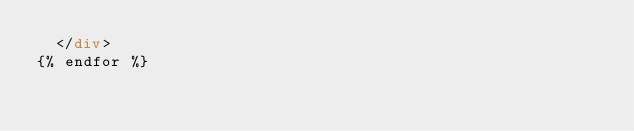<code> <loc_0><loc_0><loc_500><loc_500><_HTML_>	</div>
{% endfor %}</code> 